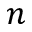<formula> <loc_0><loc_0><loc_500><loc_500>n</formula> 